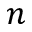<formula> <loc_0><loc_0><loc_500><loc_500>n</formula> 